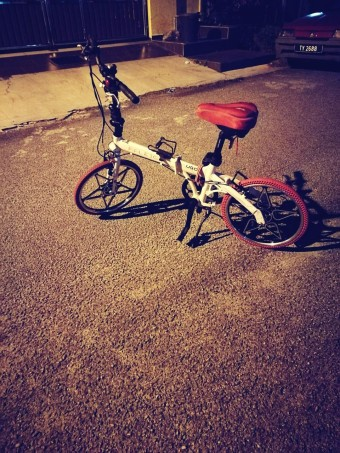How many cars would there be in the image if two additional cars were added in the scene? To accurately answer how many cars there would be if two were added to the scene, it would be essential to first know how many cars are currently present. However, the image shows a bicycle, not a car. Thus, assuming we are starting with zero cars in the scene, adding two cars would result in a total of two cars being present. 